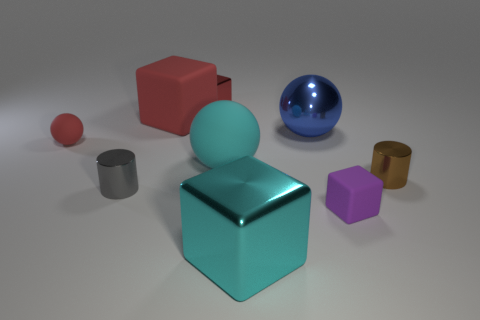Can you describe the texture and material of the purple object? The purple object appears to have a matte finish, indicating a non-reflective surface, which is often characteristic of items made from soft materials like rubber or possibly a hard matte plastic. 